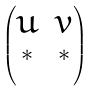Convert formula to latex. <formula><loc_0><loc_0><loc_500><loc_500>\begin{pmatrix} u & v \\ ^ { * } & ^ { * } \end{pmatrix}</formula> 